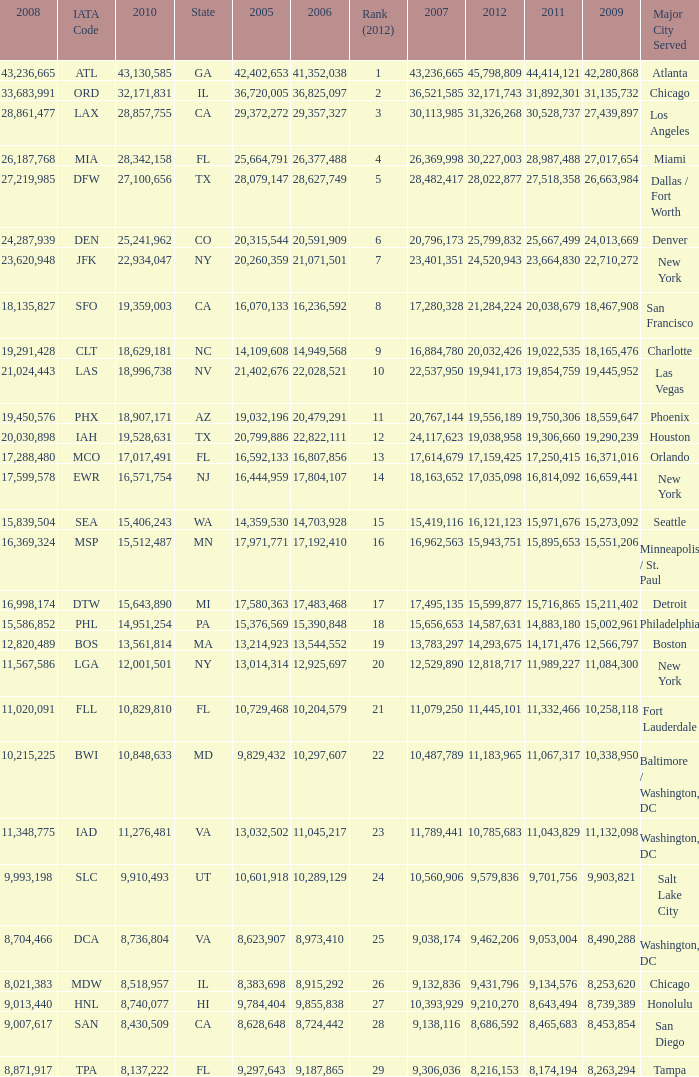When Philadelphia has a 2007 less than 20,796,173 and a 2008 more than 10,215,225, what is the smallest 2009? 15002961.0. 